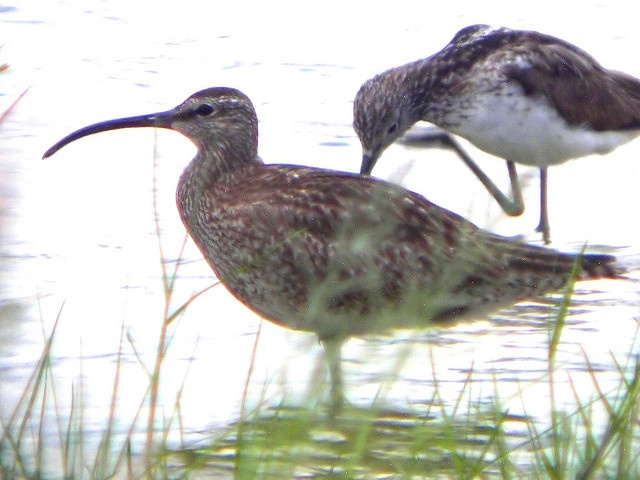Describe the objects in this image and their specific colors. I can see bird in white, gray, and darkgray tones and bird in white, gray, darkgray, and black tones in this image. 